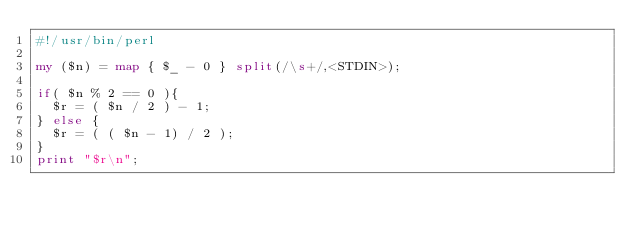<code> <loc_0><loc_0><loc_500><loc_500><_Perl_>#!/usr/bin/perl

my ($n) = map { $_ - 0 } split(/\s+/,<STDIN>);

if( $n % 2 == 0 ){
  $r = ( $n / 2 ) - 1;
} else {
  $r = ( ( $n - 1) / 2 );
}
print "$r\n";



</code> 